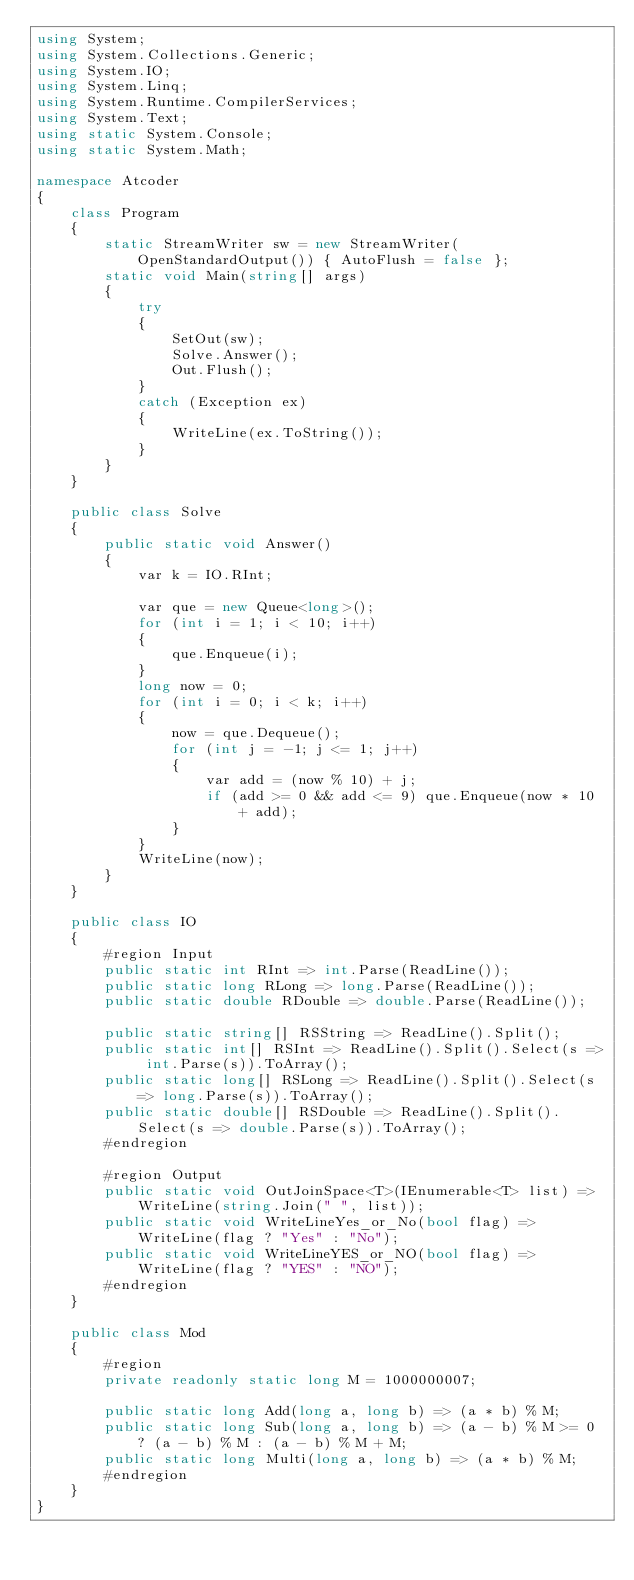<code> <loc_0><loc_0><loc_500><loc_500><_C#_>using System;
using System.Collections.Generic;
using System.IO;
using System.Linq;
using System.Runtime.CompilerServices;
using System.Text;
using static System.Console;
using static System.Math;

namespace Atcoder
{
    class Program
    {
        static StreamWriter sw = new StreamWriter(OpenStandardOutput()) { AutoFlush = false };
        static void Main(string[] args)
        {
            try
            {
                SetOut(sw);
                Solve.Answer();
                Out.Flush();
            }
            catch (Exception ex)
            {
                WriteLine(ex.ToString());
            }
        }
    }

    public class Solve
    {
        public static void Answer()
        {
            var k = IO.RInt;

            var que = new Queue<long>();
            for (int i = 1; i < 10; i++)
            {
                que.Enqueue(i);
            }
            long now = 0;
            for (int i = 0; i < k; i++)
            {
                now = que.Dequeue();
                for (int j = -1; j <= 1; j++)
                {
                    var add = (now % 10) + j;
                    if (add >= 0 && add <= 9) que.Enqueue(now * 10 + add);
                }
            }
            WriteLine(now);
        }
    }

    public class IO
    {
        #region Input
        public static int RInt => int.Parse(ReadLine());
        public static long RLong => long.Parse(ReadLine());
        public static double RDouble => double.Parse(ReadLine());

        public static string[] RSString => ReadLine().Split();
        public static int[] RSInt => ReadLine().Split().Select(s => int.Parse(s)).ToArray();
        public static long[] RSLong => ReadLine().Split().Select(s => long.Parse(s)).ToArray();
        public static double[] RSDouble => ReadLine().Split().Select(s => double.Parse(s)).ToArray();
        #endregion

        #region Output
        public static void OutJoinSpace<T>(IEnumerable<T> list) => WriteLine(string.Join(" ", list));
        public static void WriteLineYes_or_No(bool flag) => WriteLine(flag ? "Yes" : "No");
        public static void WriteLineYES_or_NO(bool flag) => WriteLine(flag ? "YES" : "NO");
        #endregion
    }

    public class Mod
    {
        #region
        private readonly static long M = 1000000007;

        public static long Add(long a, long b) => (a * b) % M;
        public static long Sub(long a, long b) => (a - b) % M >= 0 ? (a - b) % M : (a - b) % M + M;
        public static long Multi(long a, long b) => (a * b) % M;
        #endregion
    }
}</code> 